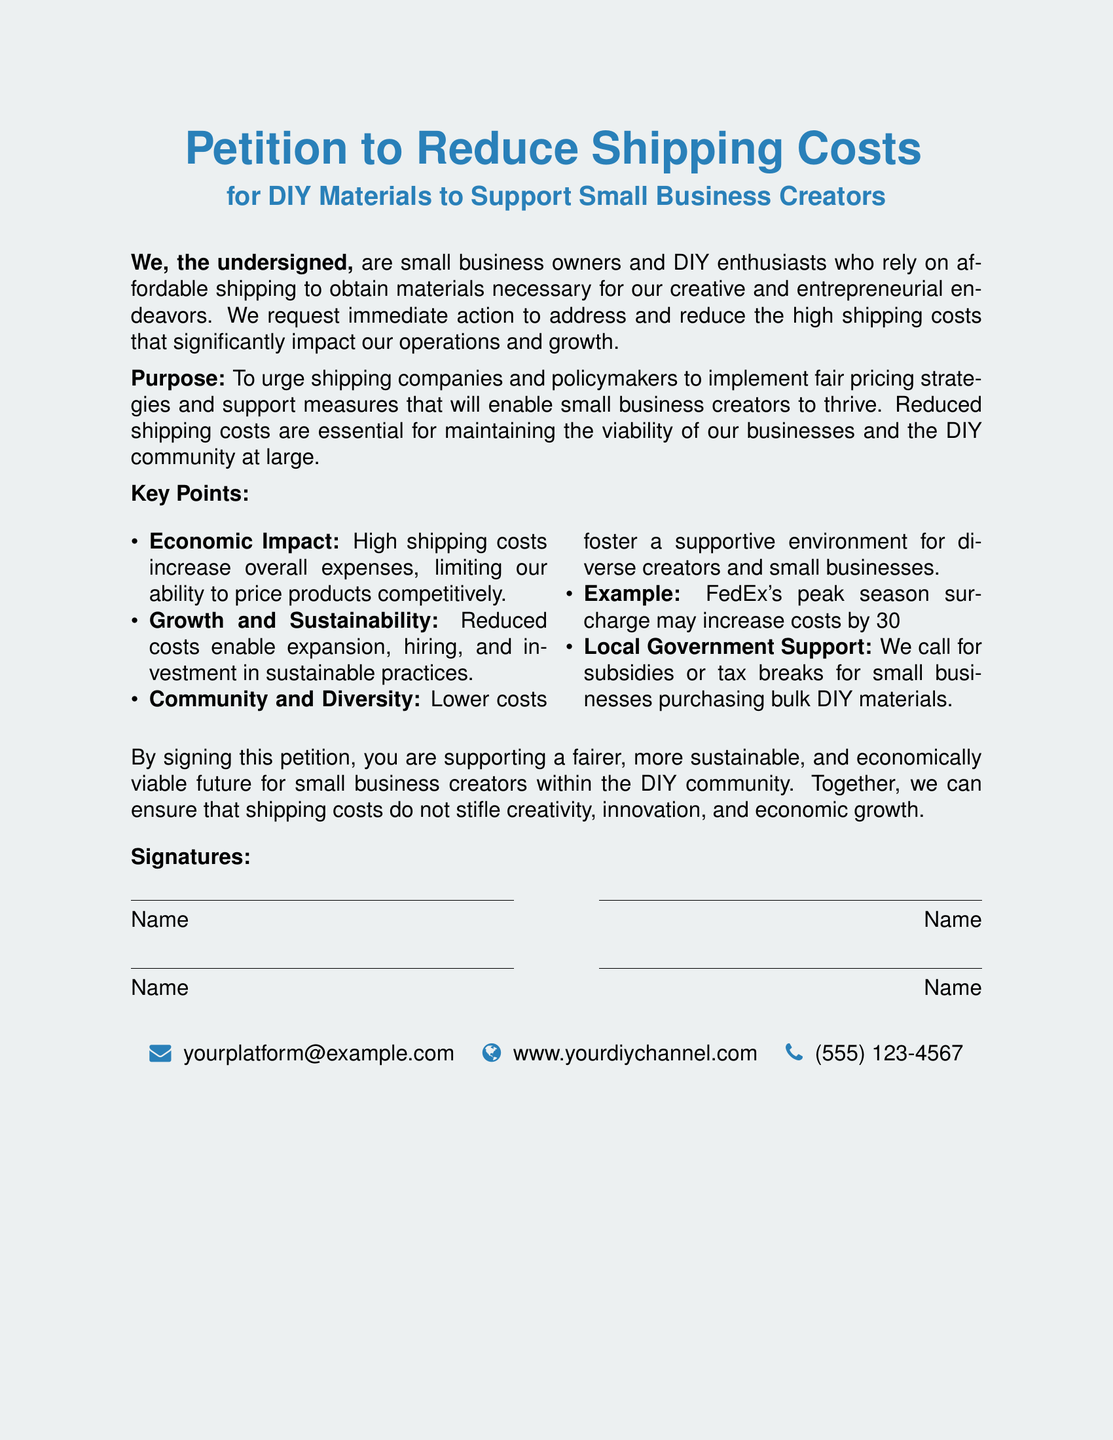What is the title of the petition? The title is found at the top of the document, stating the main focus of the petition.
Answer: Petition to Reduce Shipping Costs Who is the petition aimed at? The document indicates the primary audience to whom the petition is directed, which includes shipping companies and policymakers.
Answer: Shipping companies and policymakers What economic impact is highlighted in the petition? The document notes the effects of high shipping costs on small business operations, which limits pricing capabilities.
Answer: Higher expenses How much can shipping costs increase during FedEx's peak season? The petition provides a specific percentage as an example of potential shipping cost increases.
Answer: 30% What is one suggested support measure for small businesses mentioned in the petition? The petition lists measures sought by signers, such as subsidies or tax breaks for purchasing materials.
Answer: Subsidies or tax breaks How many signatures are indicated in the document? The document displays a section for signatories but does not specify a number, implying that it is open-ended.
Answer: Open-ended What does signing the petition support? The document states a broader goal or effect of signing, which aligns with the interests of the DIY community.
Answer: A fairer, more sustainable future What type of community does the petition aim to support? The petition mentions the specific community that the signers are part of and wish to strengthen through reduced shipping costs.
Answer: DIY community What contact information is provided in the document? The document includes various methods for contact at the end, specifying a default email format.
Answer: yourplatform@example.com 